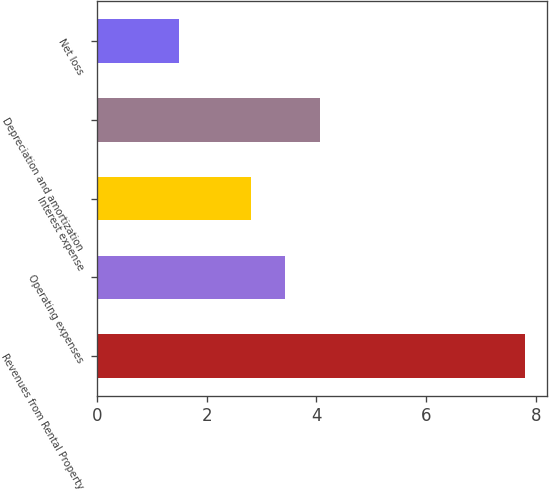<chart> <loc_0><loc_0><loc_500><loc_500><bar_chart><fcel>Revenues from Rental Property<fcel>Operating expenses<fcel>Interest expense<fcel>Depreciation and amortization<fcel>Net loss<nl><fcel>7.8<fcel>3.43<fcel>2.8<fcel>4.06<fcel>1.5<nl></chart> 